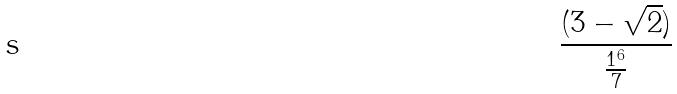<formula> <loc_0><loc_0><loc_500><loc_500>\frac { ( 3 - \sqrt { 2 } ) } { \frac { 1 ^ { 6 } } { 7 } }</formula> 